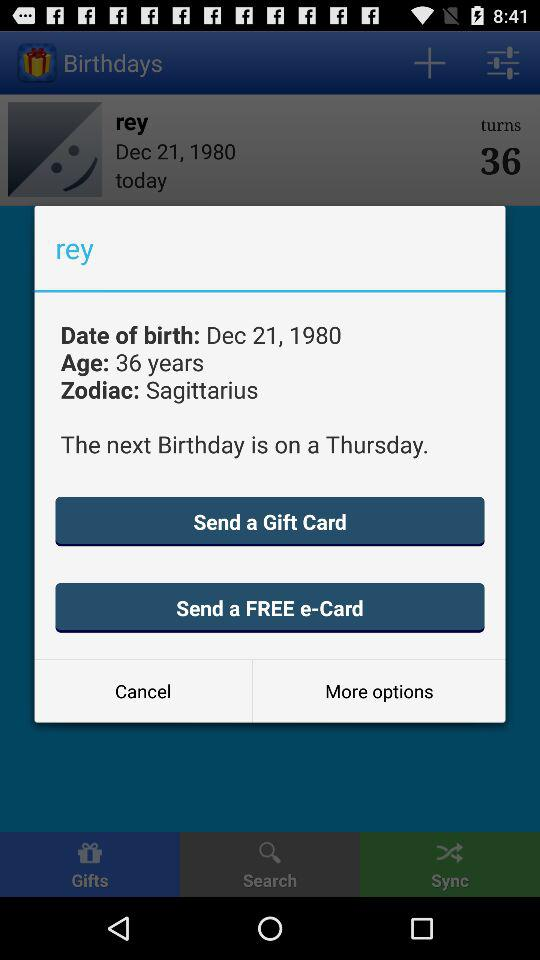How many years old is Rey?
Answer the question using a single word or phrase. 36 